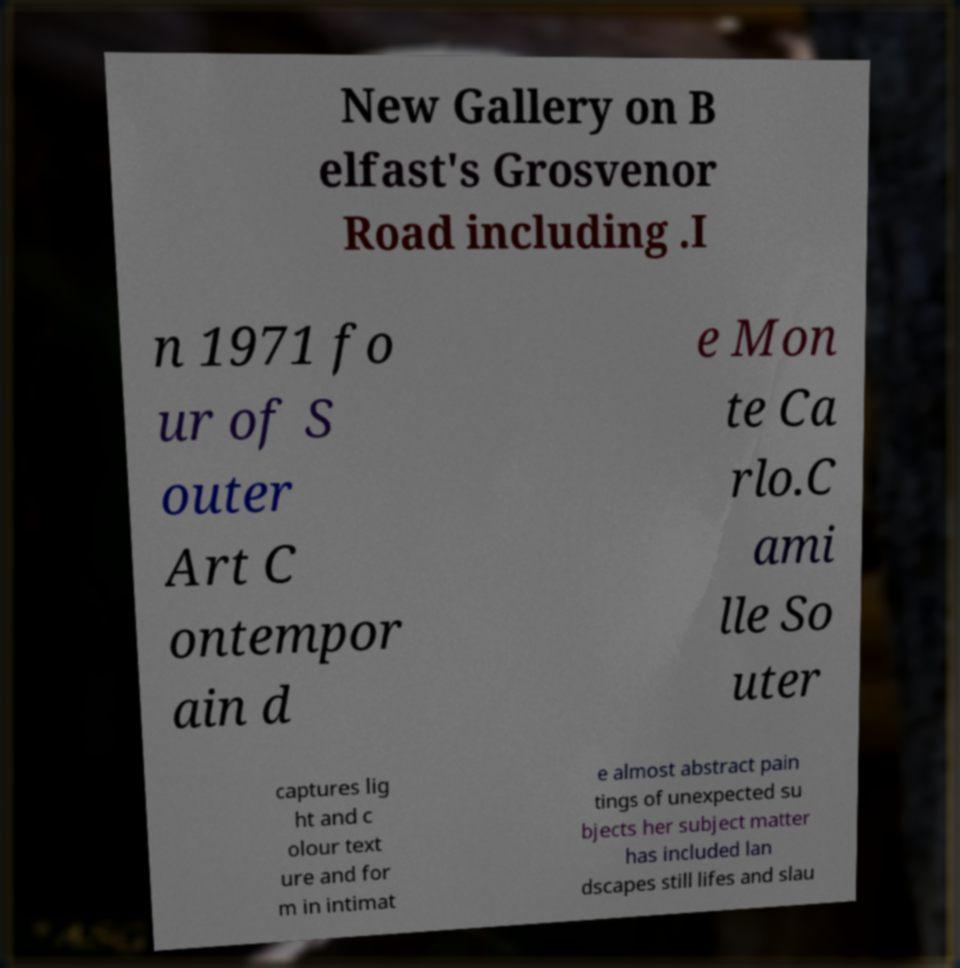Can you read and provide the text displayed in the image?This photo seems to have some interesting text. Can you extract and type it out for me? New Gallery on B elfast's Grosvenor Road including .I n 1971 fo ur of S outer Art C ontempor ain d e Mon te Ca rlo.C ami lle So uter captures lig ht and c olour text ure and for m in intimat e almost abstract pain tings of unexpected su bjects her subject matter has included lan dscapes still lifes and slau 